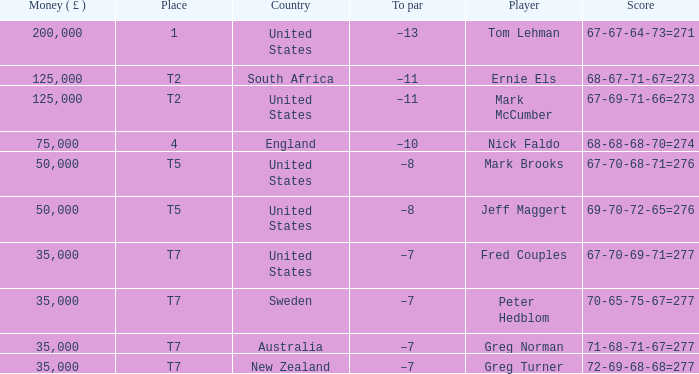What is Score, when Money ( £ ) is greater than 35,000, and when Country is "United States"? 67-67-64-73=271, 67-69-71-66=273, 67-70-68-71=276, 69-70-72-65=276. 